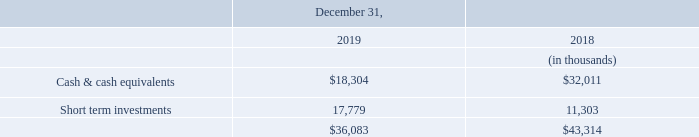Liquidity and Capital Resources
As of December 31, 2019, we had approximately $36.1 million of cash and cash equivalents and short term investments, a decrease of approximately $7.2 million from $43.3 million in 2018.
During 2018, our board of directors authorized the repurchase of issued and outstanding shares of our common stock having an aggregate value of up to $10.0 million pursuant to a share repurchase program. No shares were repurchased under this program in 2019, As of December 31, 2019, we have a remaining authorization of $8.0 million for future share repurchases.
In 2013, we made a $5 million commitment to invest in an innovation fund through JVP to invest in early-stage cyber technology companies. We sold our interest in JVP in December 2019. There is no further commitment remaining.
What is the amount of cash and cash equivalents had by the company in 2018 and 2019 respectively? $43.3 million, $36.1 million. What is the amount authorised to be spent on the share repurchase program in 2018 and what is the remaining authorization in 2019? $10.0 million, $8.0 million. What are the respective cash & cash equivalents held by the company in 2018 and 2019 respectively?
Answer scale should be: thousand. 32,011, 18,304. What is the percentage change in the cash & cash equivalents between 2018 and 2019?
Answer scale should be: percent. (18,304 - 32,011)/32,011 
Answer: -42.82. What is the percentage change in the short term investments between 2018 and 2019?
Answer scale should be: percent. (17,779 - 11,303)/11,303 
Answer: 57.29. What is the percentage change in the total liquidity and capital resources between 2018 and 2019?
Answer scale should be: percent. (36,083 - 43,314)/43,314 
Answer: -16.69. 